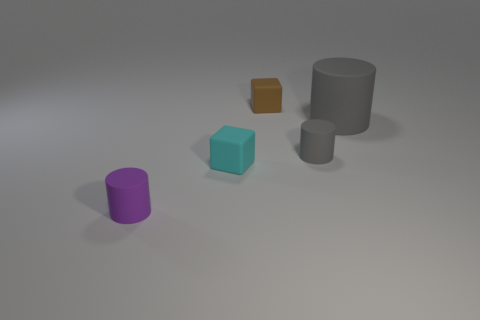Are there an equal number of tiny matte things that are to the left of the small brown rubber block and tiny cylinders behind the big rubber object?
Your response must be concise. No. What number of other objects are the same color as the large cylinder?
Your answer should be very brief. 1. Do the big cylinder and the small matte cylinder right of the small cyan object have the same color?
Your answer should be very brief. Yes. What number of purple things are big matte cylinders or cylinders?
Offer a very short reply. 1. Are there an equal number of brown matte objects in front of the brown rubber thing and small gray metal blocks?
Keep it short and to the point. Yes. There is another small matte thing that is the same shape as the tiny purple matte object; what is its color?
Your answer should be very brief. Gray. What number of other large things are the same shape as the large rubber object?
Your answer should be very brief. 0. There is another thing that is the same color as the big thing; what is it made of?
Your answer should be very brief. Rubber. How many large cylinders are there?
Offer a terse response. 1. Are there any cylinders made of the same material as the big thing?
Make the answer very short. Yes. 